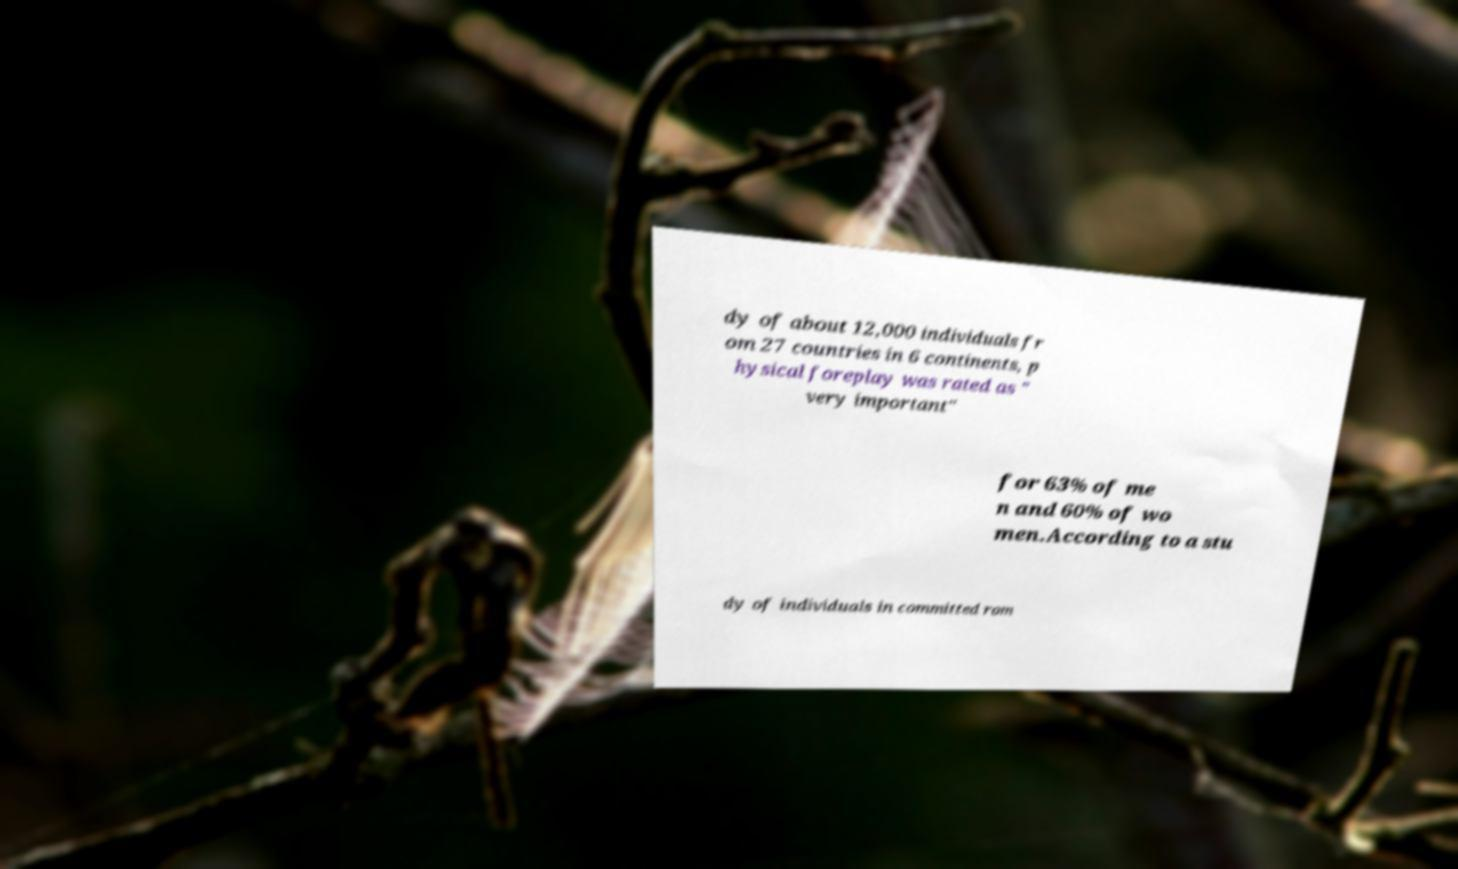What messages or text are displayed in this image? I need them in a readable, typed format. dy of about 12,000 individuals fr om 27 countries in 6 continents, p hysical foreplay was rated as " very important" for 63% of me n and 60% of wo men.According to a stu dy of individuals in committed rom 